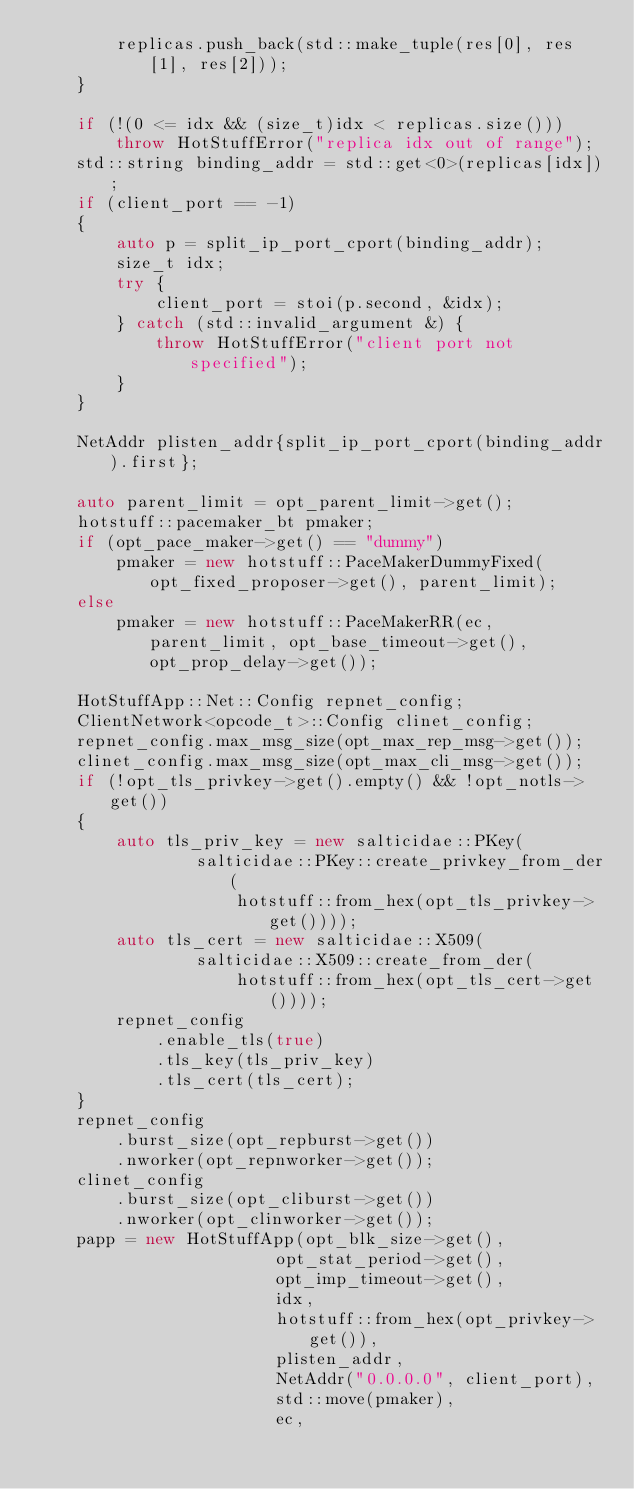Convert code to text. <code><loc_0><loc_0><loc_500><loc_500><_C++_>        replicas.push_back(std::make_tuple(res[0], res[1], res[2]));
    }

    if (!(0 <= idx && (size_t)idx < replicas.size()))
        throw HotStuffError("replica idx out of range");
    std::string binding_addr = std::get<0>(replicas[idx]);
    if (client_port == -1)
    {
        auto p = split_ip_port_cport(binding_addr);
        size_t idx;
        try {
            client_port = stoi(p.second, &idx);
        } catch (std::invalid_argument &) {
            throw HotStuffError("client port not specified");
        }
    }

    NetAddr plisten_addr{split_ip_port_cport(binding_addr).first};

    auto parent_limit = opt_parent_limit->get();
    hotstuff::pacemaker_bt pmaker;
    if (opt_pace_maker->get() == "dummy")
        pmaker = new hotstuff::PaceMakerDummyFixed(opt_fixed_proposer->get(), parent_limit);
    else
        pmaker = new hotstuff::PaceMakerRR(ec, parent_limit, opt_base_timeout->get(), opt_prop_delay->get());

    HotStuffApp::Net::Config repnet_config;
    ClientNetwork<opcode_t>::Config clinet_config;
    repnet_config.max_msg_size(opt_max_rep_msg->get());
    clinet_config.max_msg_size(opt_max_cli_msg->get());
    if (!opt_tls_privkey->get().empty() && !opt_notls->get())
    {
        auto tls_priv_key = new salticidae::PKey(
                salticidae::PKey::create_privkey_from_der(
                    hotstuff::from_hex(opt_tls_privkey->get())));
        auto tls_cert = new salticidae::X509(
                salticidae::X509::create_from_der(
                    hotstuff::from_hex(opt_tls_cert->get())));
        repnet_config
            .enable_tls(true)
            .tls_key(tls_priv_key)
            .tls_cert(tls_cert);
    }
    repnet_config
        .burst_size(opt_repburst->get())
        .nworker(opt_repnworker->get());
    clinet_config
        .burst_size(opt_cliburst->get())
        .nworker(opt_clinworker->get());
    papp = new HotStuffApp(opt_blk_size->get(),
                        opt_stat_period->get(),
                        opt_imp_timeout->get(),
                        idx,
                        hotstuff::from_hex(opt_privkey->get()),
                        plisten_addr,
                        NetAddr("0.0.0.0", client_port),
                        std::move(pmaker),
                        ec,</code> 